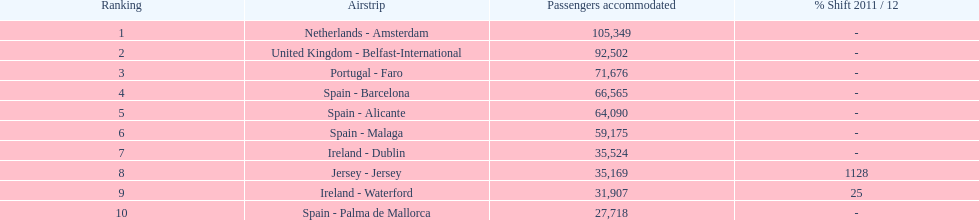What is the top destination for travelers departing from london southend airport? Netherlands - Amsterdam. 